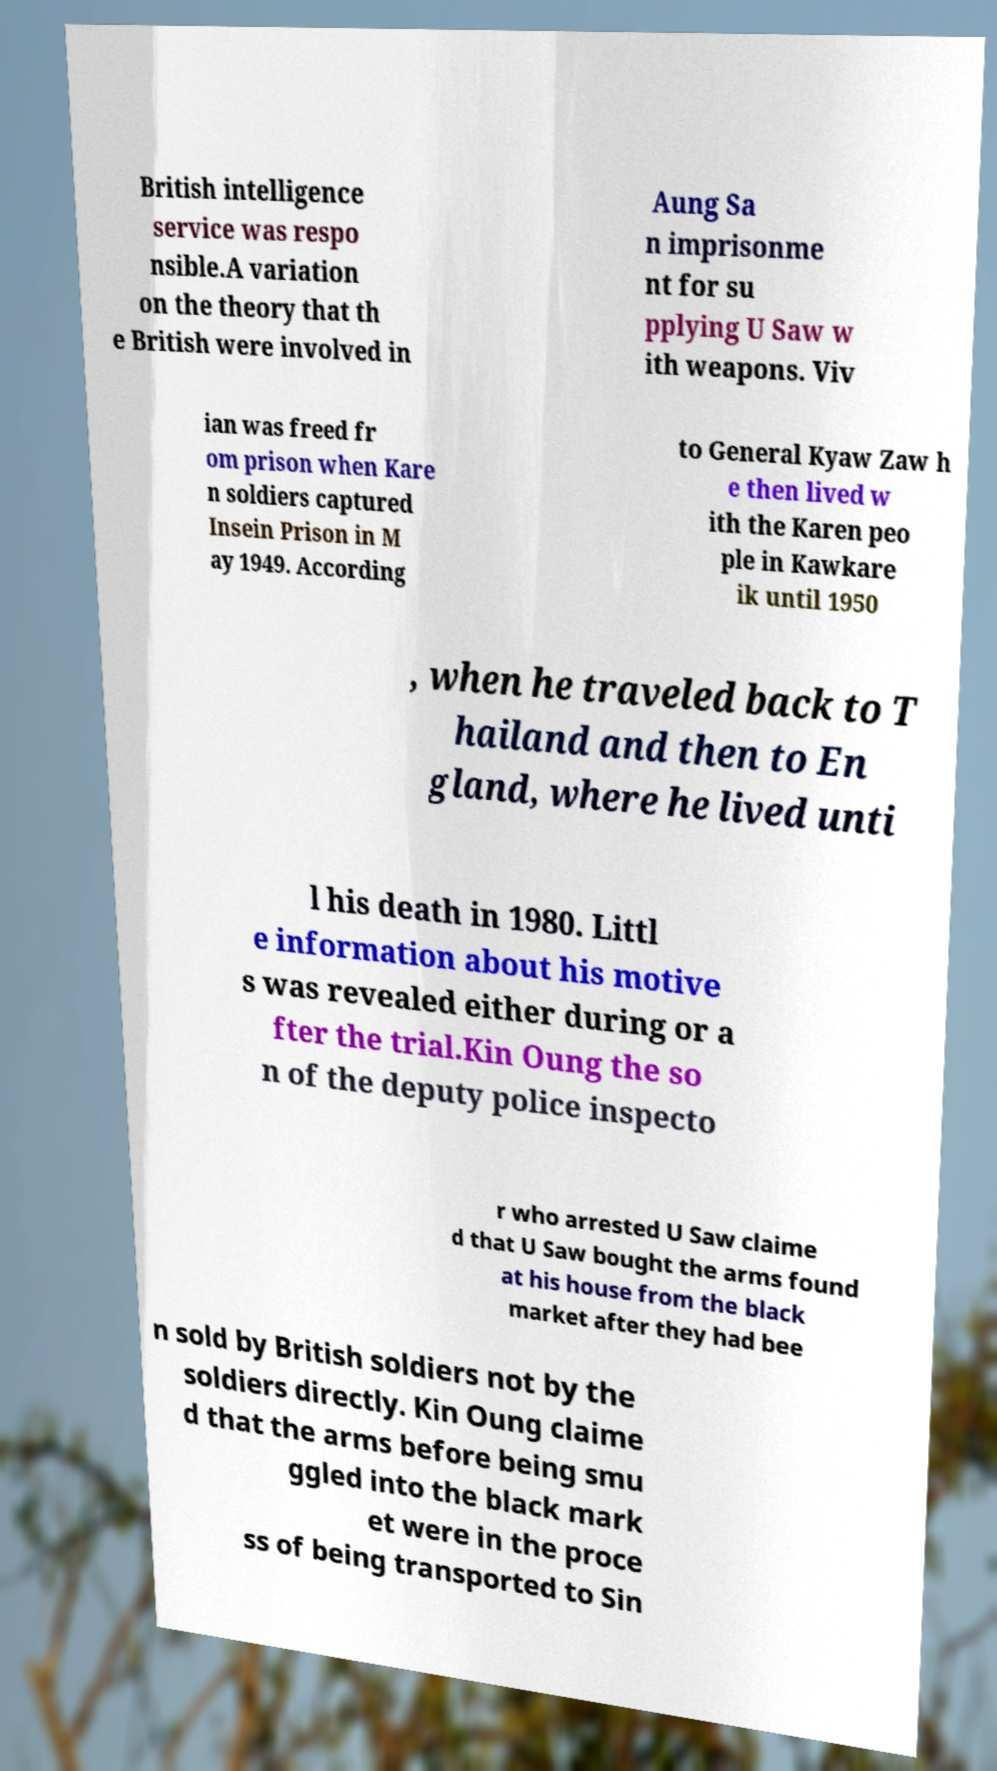Please read and relay the text visible in this image. What does it say? British intelligence service was respo nsible.A variation on the theory that th e British were involved in Aung Sa n imprisonme nt for su pplying U Saw w ith weapons. Viv ian was freed fr om prison when Kare n soldiers captured Insein Prison in M ay 1949. According to General Kyaw Zaw h e then lived w ith the Karen peo ple in Kawkare ik until 1950 , when he traveled back to T hailand and then to En gland, where he lived unti l his death in 1980. Littl e information about his motive s was revealed either during or a fter the trial.Kin Oung the so n of the deputy police inspecto r who arrested U Saw claime d that U Saw bought the arms found at his house from the black market after they had bee n sold by British soldiers not by the soldiers directly. Kin Oung claime d that the arms before being smu ggled into the black mark et were in the proce ss of being transported to Sin 